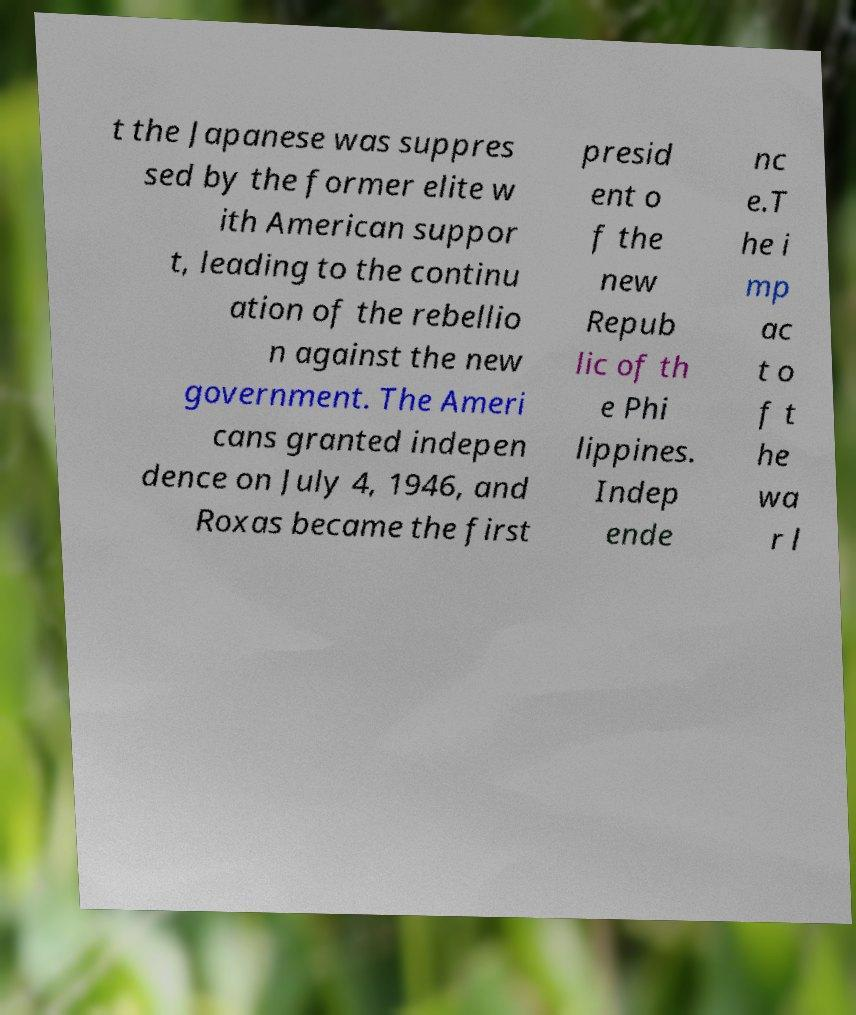Could you assist in decoding the text presented in this image and type it out clearly? t the Japanese was suppres sed by the former elite w ith American suppor t, leading to the continu ation of the rebellio n against the new government. The Ameri cans granted indepen dence on July 4, 1946, and Roxas became the first presid ent o f the new Repub lic of th e Phi lippines. Indep ende nc e.T he i mp ac t o f t he wa r l 